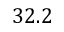<formula> <loc_0><loc_0><loc_500><loc_500>3 2 . 2</formula> 